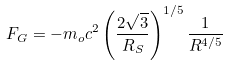Convert formula to latex. <formula><loc_0><loc_0><loc_500><loc_500>F _ { G } = - m _ { o } c ^ { 2 } \left ( \frac { 2 \sqrt { 3 } } { R _ { S } } \right ) ^ { 1 / 5 } \frac { 1 } { R ^ { 4 / 5 } }</formula> 